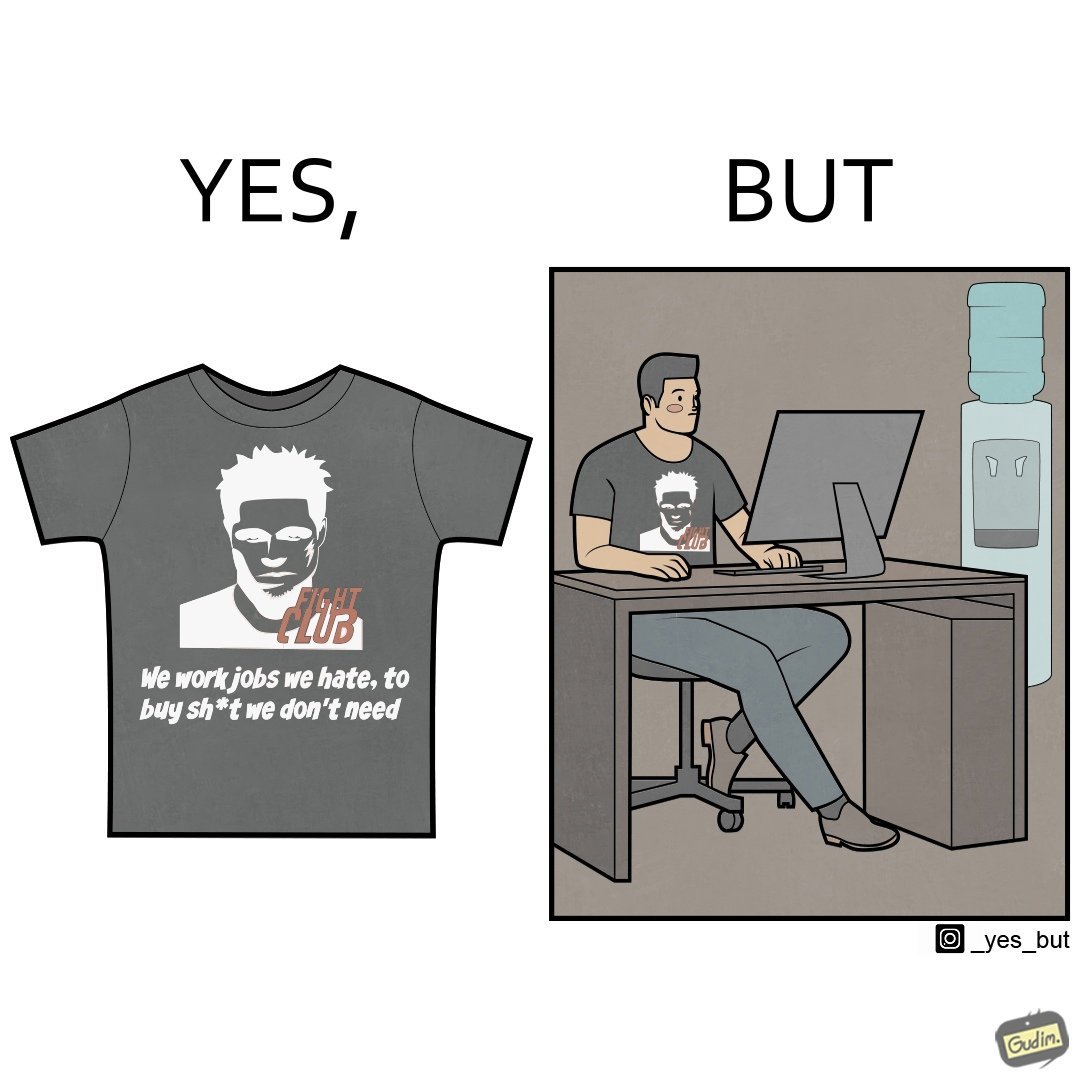Describe the contrast between the left and right parts of this image. In the left part of the image: a t-shirt with "Fight Club" written on it (referring to the movie), along with a dialogue from the movie that says "We work jobs we hate, to buy sh*t we don't need". In the right part of the image: a person wearing a t-shirt that says "Fight Club", working on a computer system, with a water dispenser by the side. 